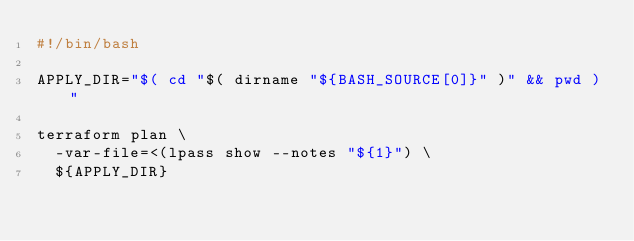Convert code to text. <code><loc_0><loc_0><loc_500><loc_500><_Bash_>#!/bin/bash

APPLY_DIR="$( cd "$( dirname "${BASH_SOURCE[0]}" )" && pwd )"

terraform plan \
  -var-file=<(lpass show --notes "${1}") \
  ${APPLY_DIR}

</code> 